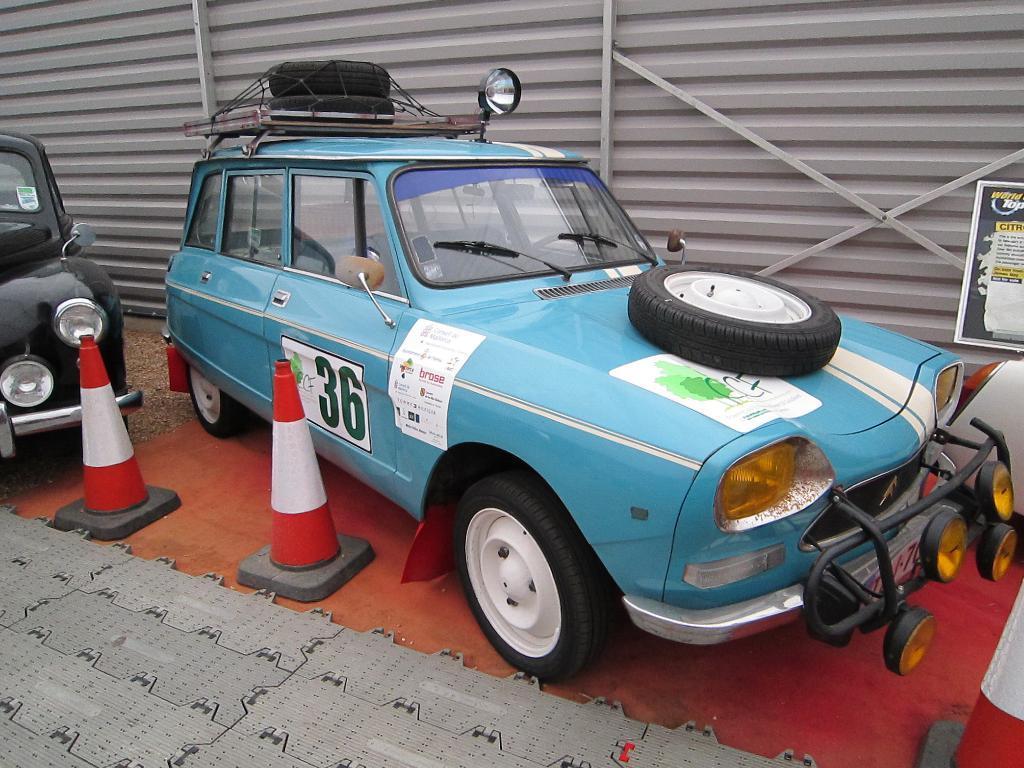Could you give a brief overview of what you see in this image? In this image I can see two vehicles in blue and black color, in front I can see two poles in red and white color. I can also see a wheel in black color. 